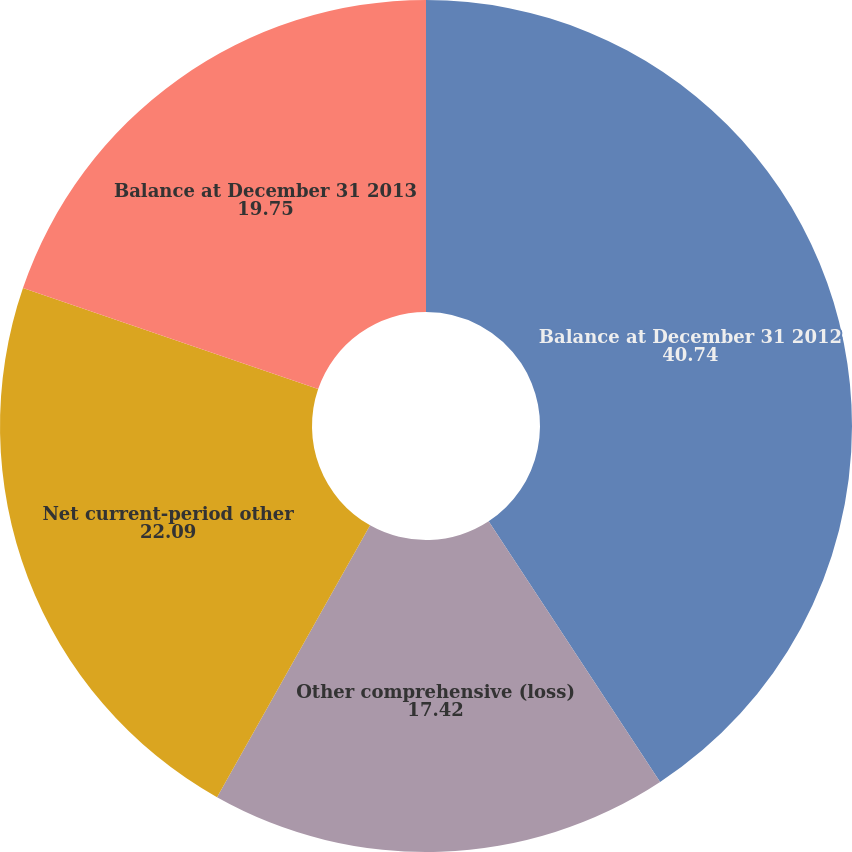Convert chart. <chart><loc_0><loc_0><loc_500><loc_500><pie_chart><fcel>Balance at December 31 2012<fcel>Other comprehensive (loss)<fcel>Net current-period other<fcel>Balance at December 31 2013<nl><fcel>40.74%<fcel>17.42%<fcel>22.09%<fcel>19.75%<nl></chart> 